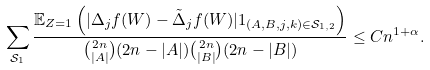<formula> <loc_0><loc_0><loc_500><loc_500>\sum _ { \mathcal { S } _ { 1 } } \frac { \mathbb { E } _ { Z = 1 } \left ( | \Delta _ { j } f ( W ) - \tilde { \Delta } _ { j } f ( W ) | 1 _ { ( A , B , j , k ) \in \mathcal { S } _ { 1 , 2 } } \right ) } { \binom { 2 n } { | A | } ( 2 n - | A | ) \binom { 2 n } { | B | } ( 2 n - | B | ) } \leq C n ^ { 1 + \alpha } .</formula> 